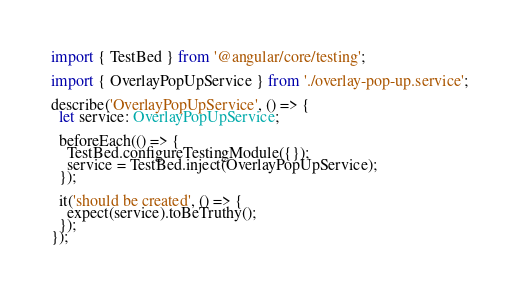Convert code to text. <code><loc_0><loc_0><loc_500><loc_500><_TypeScript_>import { TestBed } from '@angular/core/testing';

import { OverlayPopUpService } from './overlay-pop-up.service';

describe('OverlayPopUpService', () => {
  let service: OverlayPopUpService;

  beforeEach(() => {
    TestBed.configureTestingModule({});
    service = TestBed.inject(OverlayPopUpService);
  });

  it('should be created', () => {
    expect(service).toBeTruthy();
  });
});
</code> 